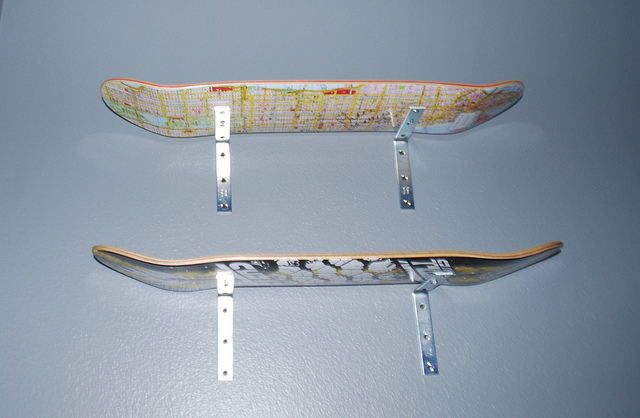Please extract the text content from this image. i 